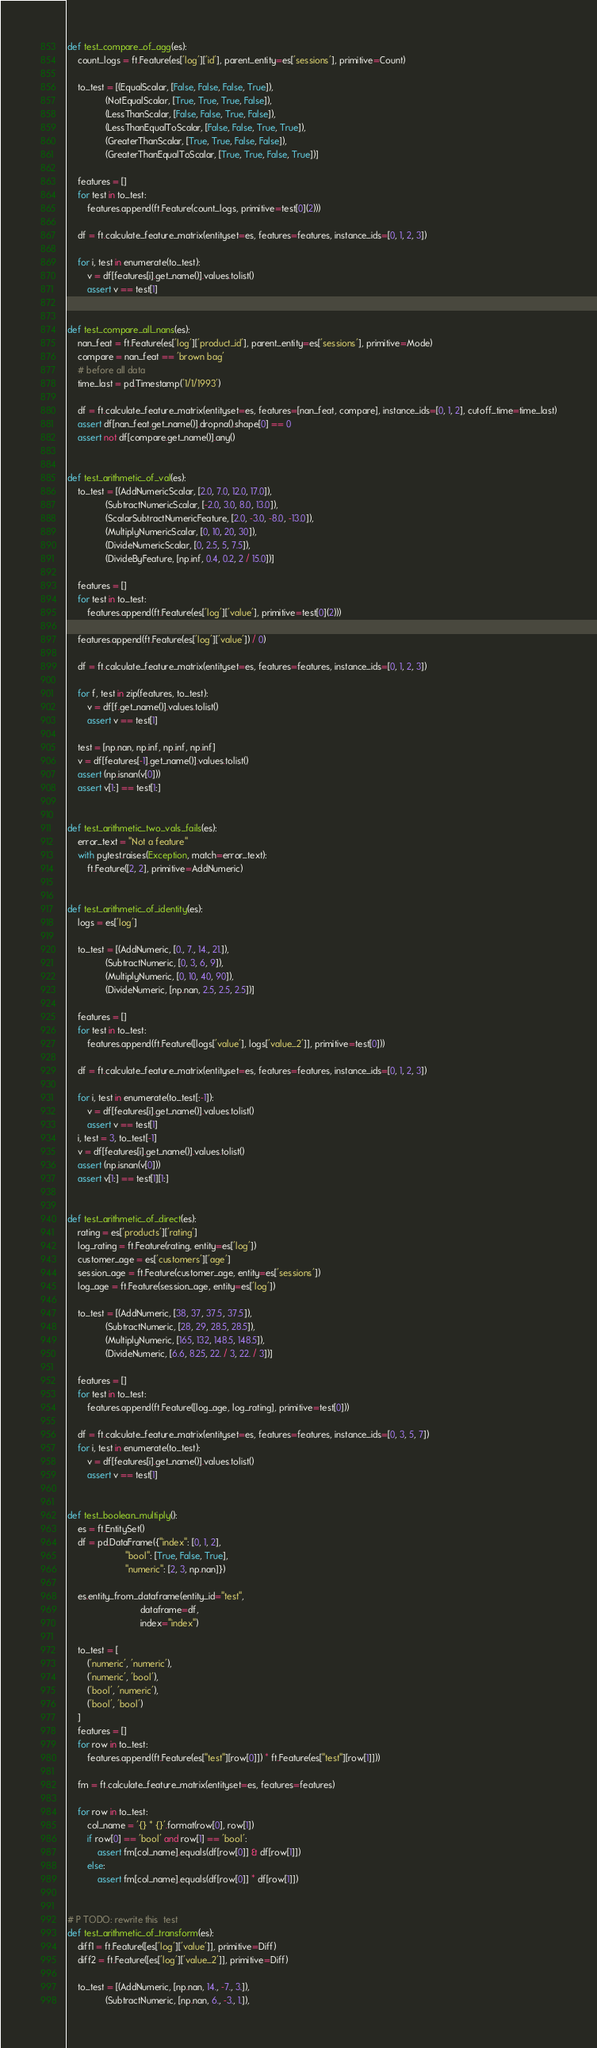<code> <loc_0><loc_0><loc_500><loc_500><_Python_>
def test_compare_of_agg(es):
    count_logs = ft.Feature(es['log']['id'], parent_entity=es['sessions'], primitive=Count)

    to_test = [(EqualScalar, [False, False, False, True]),
               (NotEqualScalar, [True, True, True, False]),
               (LessThanScalar, [False, False, True, False]),
               (LessThanEqualToScalar, [False, False, True, True]),
               (GreaterThanScalar, [True, True, False, False]),
               (GreaterThanEqualToScalar, [True, True, False, True])]

    features = []
    for test in to_test:
        features.append(ft.Feature(count_logs, primitive=test[0](2)))

    df = ft.calculate_feature_matrix(entityset=es, features=features, instance_ids=[0, 1, 2, 3])

    for i, test in enumerate(to_test):
        v = df[features[i].get_name()].values.tolist()
        assert v == test[1]


def test_compare_all_nans(es):
    nan_feat = ft.Feature(es['log']['product_id'], parent_entity=es['sessions'], primitive=Mode)
    compare = nan_feat == 'brown bag'
    # before all data
    time_last = pd.Timestamp('1/1/1993')

    df = ft.calculate_feature_matrix(entityset=es, features=[nan_feat, compare], instance_ids=[0, 1, 2], cutoff_time=time_last)
    assert df[nan_feat.get_name()].dropna().shape[0] == 0
    assert not df[compare.get_name()].any()


def test_arithmetic_of_val(es):
    to_test = [(AddNumericScalar, [2.0, 7.0, 12.0, 17.0]),
               (SubtractNumericScalar, [-2.0, 3.0, 8.0, 13.0]),
               (ScalarSubtractNumericFeature, [2.0, -3.0, -8.0, -13.0]),
               (MultiplyNumericScalar, [0, 10, 20, 30]),
               (DivideNumericScalar, [0, 2.5, 5, 7.5]),
               (DivideByFeature, [np.inf, 0.4, 0.2, 2 / 15.0])]

    features = []
    for test in to_test:
        features.append(ft.Feature(es['log']['value'], primitive=test[0](2)))

    features.append(ft.Feature(es['log']['value']) / 0)

    df = ft.calculate_feature_matrix(entityset=es, features=features, instance_ids=[0, 1, 2, 3])

    for f, test in zip(features, to_test):
        v = df[f.get_name()].values.tolist()
        assert v == test[1]

    test = [np.nan, np.inf, np.inf, np.inf]
    v = df[features[-1].get_name()].values.tolist()
    assert (np.isnan(v[0]))
    assert v[1:] == test[1:]


def test_arithmetic_two_vals_fails(es):
    error_text = "Not a feature"
    with pytest.raises(Exception, match=error_text):
        ft.Feature([2, 2], primitive=AddNumeric)


def test_arithmetic_of_identity(es):
    logs = es['log']

    to_test = [(AddNumeric, [0., 7., 14., 21.]),
               (SubtractNumeric, [0, 3, 6, 9]),
               (MultiplyNumeric, [0, 10, 40, 90]),
               (DivideNumeric, [np.nan, 2.5, 2.5, 2.5])]

    features = []
    for test in to_test:
        features.append(ft.Feature([logs['value'], logs['value_2']], primitive=test[0]))

    df = ft.calculate_feature_matrix(entityset=es, features=features, instance_ids=[0, 1, 2, 3])

    for i, test in enumerate(to_test[:-1]):
        v = df[features[i].get_name()].values.tolist()
        assert v == test[1]
    i, test = 3, to_test[-1]
    v = df[features[i].get_name()].values.tolist()
    assert (np.isnan(v[0]))
    assert v[1:] == test[1][1:]


def test_arithmetic_of_direct(es):
    rating = es['products']['rating']
    log_rating = ft.Feature(rating, entity=es['log'])
    customer_age = es['customers']['age']
    session_age = ft.Feature(customer_age, entity=es['sessions'])
    log_age = ft.Feature(session_age, entity=es['log'])

    to_test = [(AddNumeric, [38, 37, 37.5, 37.5]),
               (SubtractNumeric, [28, 29, 28.5, 28.5]),
               (MultiplyNumeric, [165, 132, 148.5, 148.5]),
               (DivideNumeric, [6.6, 8.25, 22. / 3, 22. / 3])]

    features = []
    for test in to_test:
        features.append(ft.Feature([log_age, log_rating], primitive=test[0]))

    df = ft.calculate_feature_matrix(entityset=es, features=features, instance_ids=[0, 3, 5, 7])
    for i, test in enumerate(to_test):
        v = df[features[i].get_name()].values.tolist()
        assert v == test[1]


def test_boolean_multiply():
    es = ft.EntitySet()
    df = pd.DataFrame({"index": [0, 1, 2],
                       "bool": [True, False, True],
                       "numeric": [2, 3, np.nan]})

    es.entity_from_dataframe(entity_id="test",
                             dataframe=df,
                             index="index")

    to_test = [
        ('numeric', 'numeric'),
        ('numeric', 'bool'),
        ('bool', 'numeric'),
        ('bool', 'bool')
    ]
    features = []
    for row in to_test:
        features.append(ft.Feature(es["test"][row[0]]) * ft.Feature(es["test"][row[1]]))

    fm = ft.calculate_feature_matrix(entityset=es, features=features)

    for row in to_test:
        col_name = '{} * {}'.format(row[0], row[1])
        if row[0] == 'bool' and row[1] == 'bool':
            assert fm[col_name].equals(df[row[0]] & df[row[1]])
        else:
            assert fm[col_name].equals(df[row[0]] * df[row[1]])


# P TODO: rewrite this  test
def test_arithmetic_of_transform(es):
    diff1 = ft.Feature([es['log']['value']], primitive=Diff)
    diff2 = ft.Feature([es['log']['value_2']], primitive=Diff)

    to_test = [(AddNumeric, [np.nan, 14., -7., 3.]),
               (SubtractNumeric, [np.nan, 6., -3., 1.]),</code> 